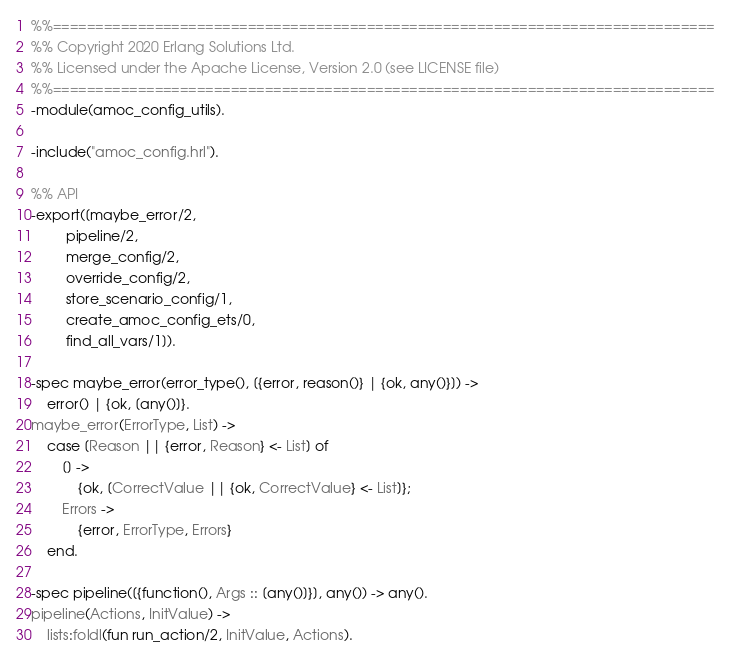Convert code to text. <code><loc_0><loc_0><loc_500><loc_500><_Erlang_>%%==============================================================================
%% Copyright 2020 Erlang Solutions Ltd.
%% Licensed under the Apache License, Version 2.0 (see LICENSE file)
%%==============================================================================
-module(amoc_config_utils).

-include("amoc_config.hrl").

%% API
-export([maybe_error/2,
         pipeline/2,
         merge_config/2,
         override_config/2,
         store_scenario_config/1,
         create_amoc_config_ets/0,
         find_all_vars/1]).

-spec maybe_error(error_type(), [{error, reason()} | {ok, any()}]) ->
    error() | {ok, [any()]}.
maybe_error(ErrorType, List) ->
    case [Reason || {error, Reason} <- List] of
        [] ->
            {ok, [CorrectValue || {ok, CorrectValue} <- List]};
        Errors ->
            {error, ErrorType, Errors}
    end.

-spec pipeline([{function(), Args :: [any()]}], any()) -> any().
pipeline(Actions, InitValue) ->
    lists:foldl(fun run_action/2, InitValue, Actions).
</code> 